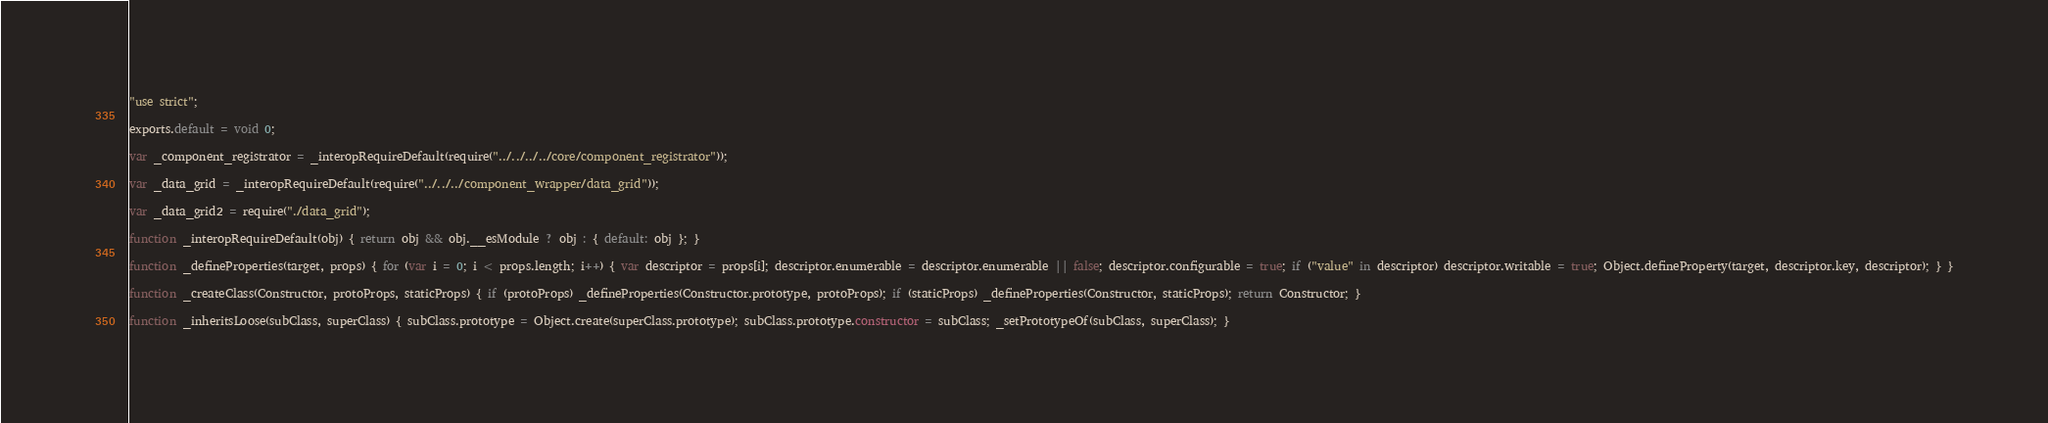Convert code to text. <code><loc_0><loc_0><loc_500><loc_500><_JavaScript_>"use strict";

exports.default = void 0;

var _component_registrator = _interopRequireDefault(require("../../../../core/component_registrator"));

var _data_grid = _interopRequireDefault(require("../../../component_wrapper/data_grid"));

var _data_grid2 = require("./data_grid");

function _interopRequireDefault(obj) { return obj && obj.__esModule ? obj : { default: obj }; }

function _defineProperties(target, props) { for (var i = 0; i < props.length; i++) { var descriptor = props[i]; descriptor.enumerable = descriptor.enumerable || false; descriptor.configurable = true; if ("value" in descriptor) descriptor.writable = true; Object.defineProperty(target, descriptor.key, descriptor); } }

function _createClass(Constructor, protoProps, staticProps) { if (protoProps) _defineProperties(Constructor.prototype, protoProps); if (staticProps) _defineProperties(Constructor, staticProps); return Constructor; }

function _inheritsLoose(subClass, superClass) { subClass.prototype = Object.create(superClass.prototype); subClass.prototype.constructor = subClass; _setPrototypeOf(subClass, superClass); }
</code> 